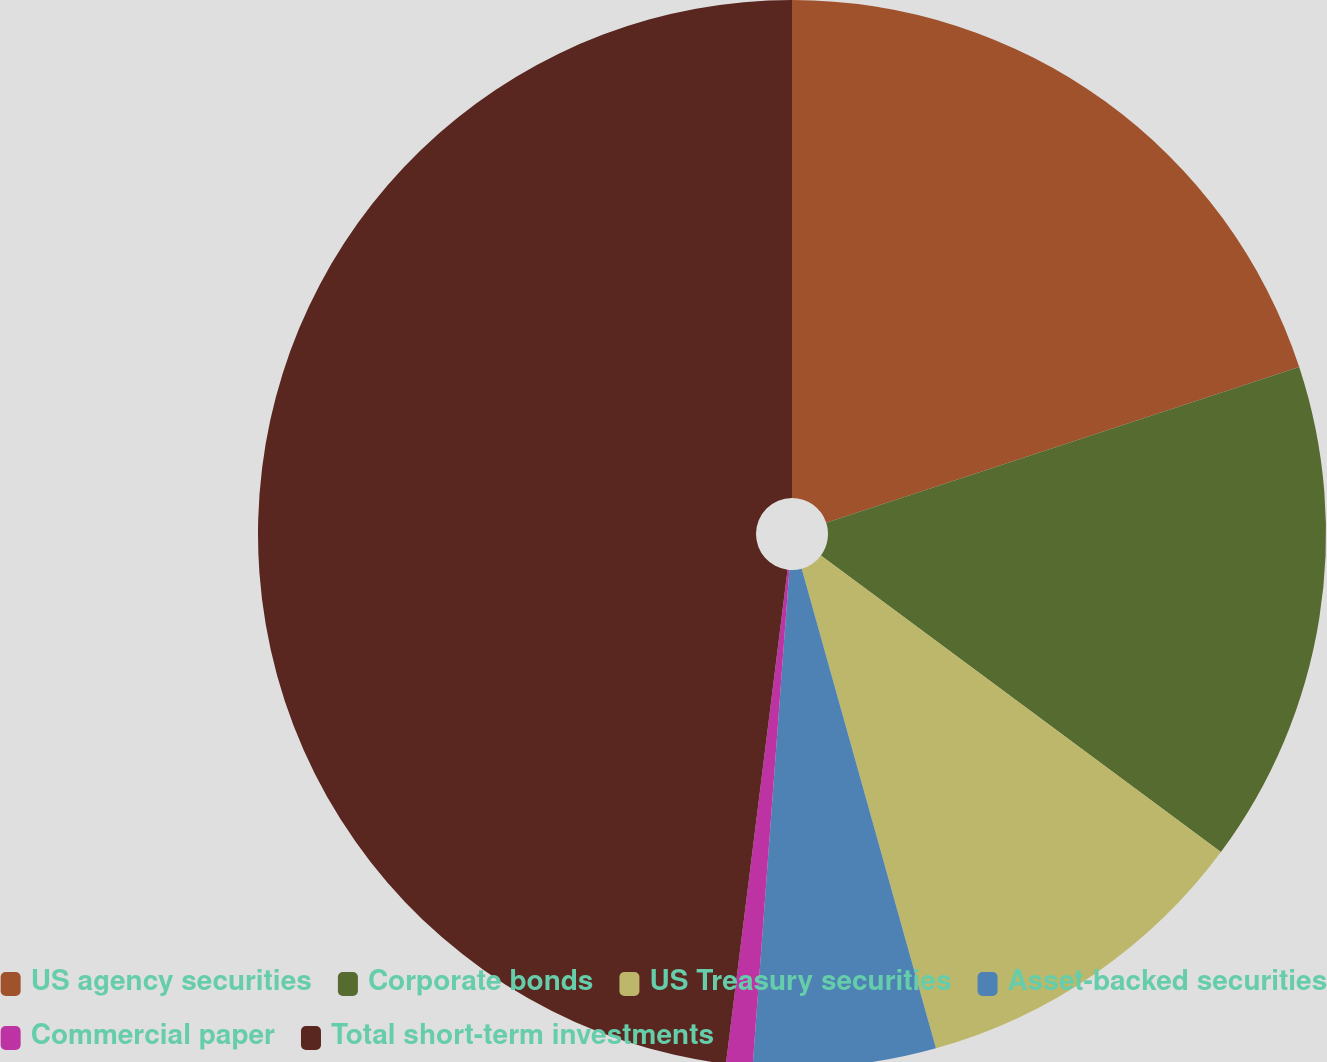<chart> <loc_0><loc_0><loc_500><loc_500><pie_chart><fcel>US agency securities<fcel>Corporate bonds<fcel>US Treasury securities<fcel>Asset-backed securities<fcel>Commercial paper<fcel>Total short-term investments<nl><fcel>19.94%<fcel>15.22%<fcel>10.5%<fcel>5.52%<fcel>0.8%<fcel>48.03%<nl></chart> 